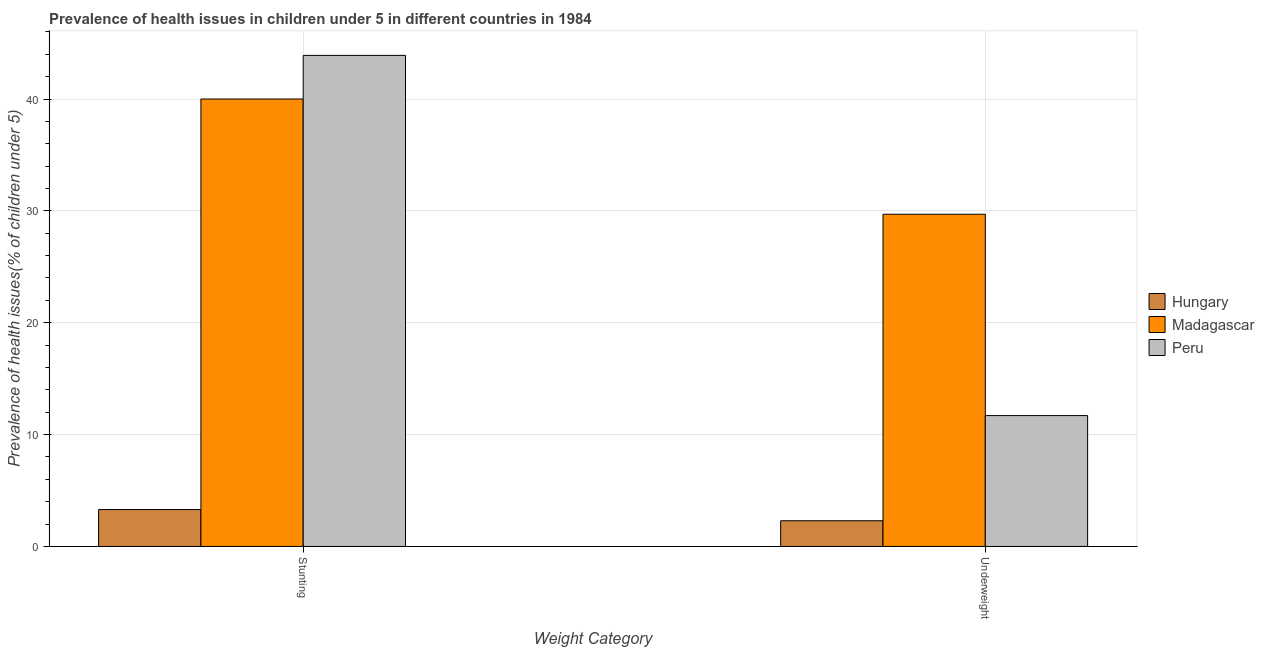How many groups of bars are there?
Provide a succinct answer. 2. How many bars are there on the 1st tick from the left?
Provide a succinct answer. 3. How many bars are there on the 2nd tick from the right?
Give a very brief answer. 3. What is the label of the 1st group of bars from the left?
Ensure brevity in your answer.  Stunting. What is the percentage of stunted children in Madagascar?
Give a very brief answer. 40. Across all countries, what is the maximum percentage of stunted children?
Offer a very short reply. 43.9. Across all countries, what is the minimum percentage of stunted children?
Provide a succinct answer. 3.3. In which country was the percentage of stunted children maximum?
Ensure brevity in your answer.  Peru. In which country was the percentage of stunted children minimum?
Ensure brevity in your answer.  Hungary. What is the total percentage of stunted children in the graph?
Ensure brevity in your answer.  87.2. What is the difference between the percentage of stunted children in Madagascar and that in Peru?
Keep it short and to the point. -3.9. What is the difference between the percentage of underweight children in Hungary and the percentage of stunted children in Madagascar?
Keep it short and to the point. -37.7. What is the average percentage of stunted children per country?
Provide a succinct answer. 29.07. What is the ratio of the percentage of stunted children in Hungary to that in Madagascar?
Keep it short and to the point. 0.08. What does the 1st bar from the left in Stunting represents?
Your response must be concise. Hungary. What does the 3rd bar from the right in Underweight represents?
Your response must be concise. Hungary. How many bars are there?
Make the answer very short. 6. Are all the bars in the graph horizontal?
Provide a short and direct response. No. How many countries are there in the graph?
Your answer should be very brief. 3. What is the difference between two consecutive major ticks on the Y-axis?
Give a very brief answer. 10. Are the values on the major ticks of Y-axis written in scientific E-notation?
Keep it short and to the point. No. Where does the legend appear in the graph?
Your response must be concise. Center right. How many legend labels are there?
Provide a succinct answer. 3. What is the title of the graph?
Provide a succinct answer. Prevalence of health issues in children under 5 in different countries in 1984. Does "Romania" appear as one of the legend labels in the graph?
Offer a very short reply. No. What is the label or title of the X-axis?
Keep it short and to the point. Weight Category. What is the label or title of the Y-axis?
Your answer should be very brief. Prevalence of health issues(% of children under 5). What is the Prevalence of health issues(% of children under 5) of Hungary in Stunting?
Make the answer very short. 3.3. What is the Prevalence of health issues(% of children under 5) in Madagascar in Stunting?
Your answer should be very brief. 40. What is the Prevalence of health issues(% of children under 5) of Peru in Stunting?
Provide a short and direct response. 43.9. What is the Prevalence of health issues(% of children under 5) in Hungary in Underweight?
Your answer should be very brief. 2.3. What is the Prevalence of health issues(% of children under 5) of Madagascar in Underweight?
Offer a terse response. 29.7. What is the Prevalence of health issues(% of children under 5) in Peru in Underweight?
Ensure brevity in your answer.  11.7. Across all Weight Category, what is the maximum Prevalence of health issues(% of children under 5) of Hungary?
Your answer should be very brief. 3.3. Across all Weight Category, what is the maximum Prevalence of health issues(% of children under 5) in Madagascar?
Offer a terse response. 40. Across all Weight Category, what is the maximum Prevalence of health issues(% of children under 5) in Peru?
Offer a terse response. 43.9. Across all Weight Category, what is the minimum Prevalence of health issues(% of children under 5) of Hungary?
Offer a very short reply. 2.3. Across all Weight Category, what is the minimum Prevalence of health issues(% of children under 5) of Madagascar?
Keep it short and to the point. 29.7. Across all Weight Category, what is the minimum Prevalence of health issues(% of children under 5) of Peru?
Ensure brevity in your answer.  11.7. What is the total Prevalence of health issues(% of children under 5) of Hungary in the graph?
Provide a succinct answer. 5.6. What is the total Prevalence of health issues(% of children under 5) in Madagascar in the graph?
Your response must be concise. 69.7. What is the total Prevalence of health issues(% of children under 5) in Peru in the graph?
Give a very brief answer. 55.6. What is the difference between the Prevalence of health issues(% of children under 5) of Peru in Stunting and that in Underweight?
Offer a terse response. 32.2. What is the difference between the Prevalence of health issues(% of children under 5) in Hungary in Stunting and the Prevalence of health issues(% of children under 5) in Madagascar in Underweight?
Your answer should be compact. -26.4. What is the difference between the Prevalence of health issues(% of children under 5) in Hungary in Stunting and the Prevalence of health issues(% of children under 5) in Peru in Underweight?
Ensure brevity in your answer.  -8.4. What is the difference between the Prevalence of health issues(% of children under 5) of Madagascar in Stunting and the Prevalence of health issues(% of children under 5) of Peru in Underweight?
Make the answer very short. 28.3. What is the average Prevalence of health issues(% of children under 5) of Hungary per Weight Category?
Provide a short and direct response. 2.8. What is the average Prevalence of health issues(% of children under 5) of Madagascar per Weight Category?
Make the answer very short. 34.85. What is the average Prevalence of health issues(% of children under 5) of Peru per Weight Category?
Make the answer very short. 27.8. What is the difference between the Prevalence of health issues(% of children under 5) in Hungary and Prevalence of health issues(% of children under 5) in Madagascar in Stunting?
Ensure brevity in your answer.  -36.7. What is the difference between the Prevalence of health issues(% of children under 5) of Hungary and Prevalence of health issues(% of children under 5) of Peru in Stunting?
Your answer should be very brief. -40.6. What is the difference between the Prevalence of health issues(% of children under 5) of Hungary and Prevalence of health issues(% of children under 5) of Madagascar in Underweight?
Provide a short and direct response. -27.4. What is the ratio of the Prevalence of health issues(% of children under 5) of Hungary in Stunting to that in Underweight?
Offer a terse response. 1.43. What is the ratio of the Prevalence of health issues(% of children under 5) in Madagascar in Stunting to that in Underweight?
Ensure brevity in your answer.  1.35. What is the ratio of the Prevalence of health issues(% of children under 5) of Peru in Stunting to that in Underweight?
Keep it short and to the point. 3.75. What is the difference between the highest and the second highest Prevalence of health issues(% of children under 5) in Hungary?
Provide a succinct answer. 1. What is the difference between the highest and the second highest Prevalence of health issues(% of children under 5) in Madagascar?
Your response must be concise. 10.3. What is the difference between the highest and the second highest Prevalence of health issues(% of children under 5) in Peru?
Offer a terse response. 32.2. What is the difference between the highest and the lowest Prevalence of health issues(% of children under 5) in Hungary?
Offer a very short reply. 1. What is the difference between the highest and the lowest Prevalence of health issues(% of children under 5) of Madagascar?
Your answer should be compact. 10.3. What is the difference between the highest and the lowest Prevalence of health issues(% of children under 5) of Peru?
Keep it short and to the point. 32.2. 